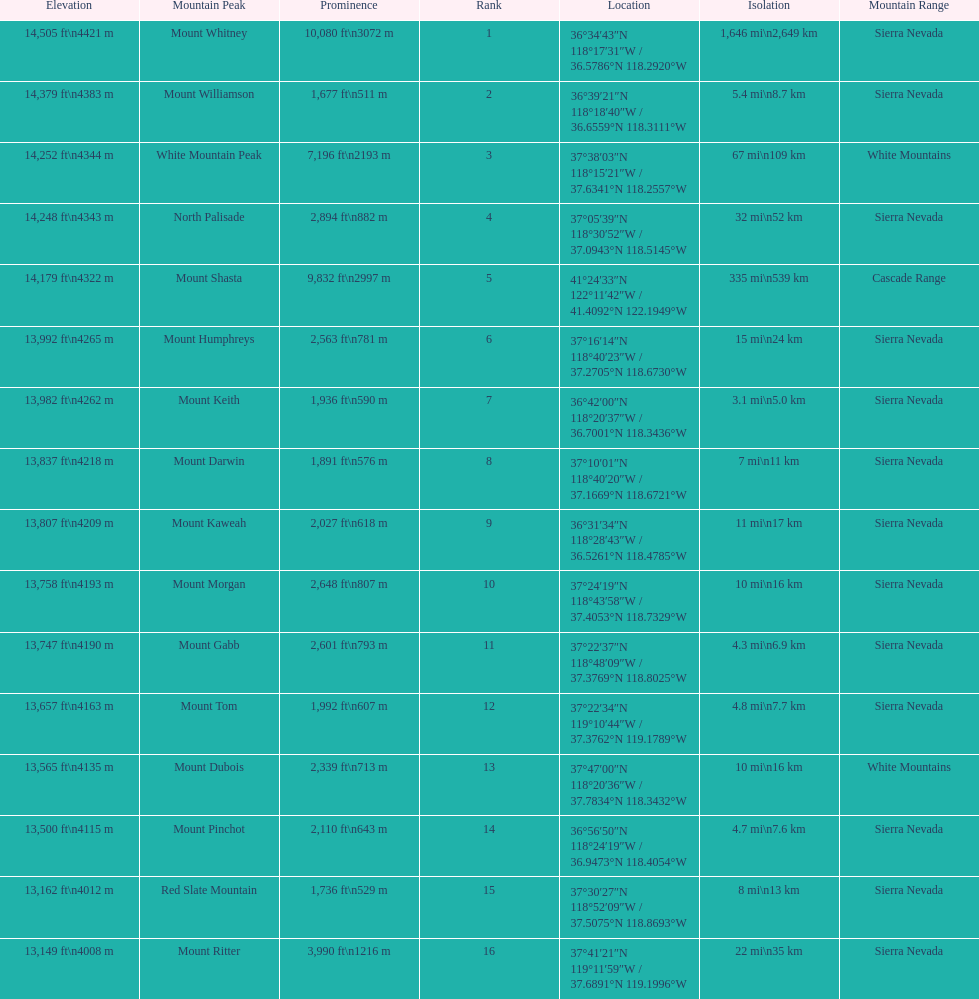Which is taller, mount humphreys or mount kaweah. Mount Humphreys. 